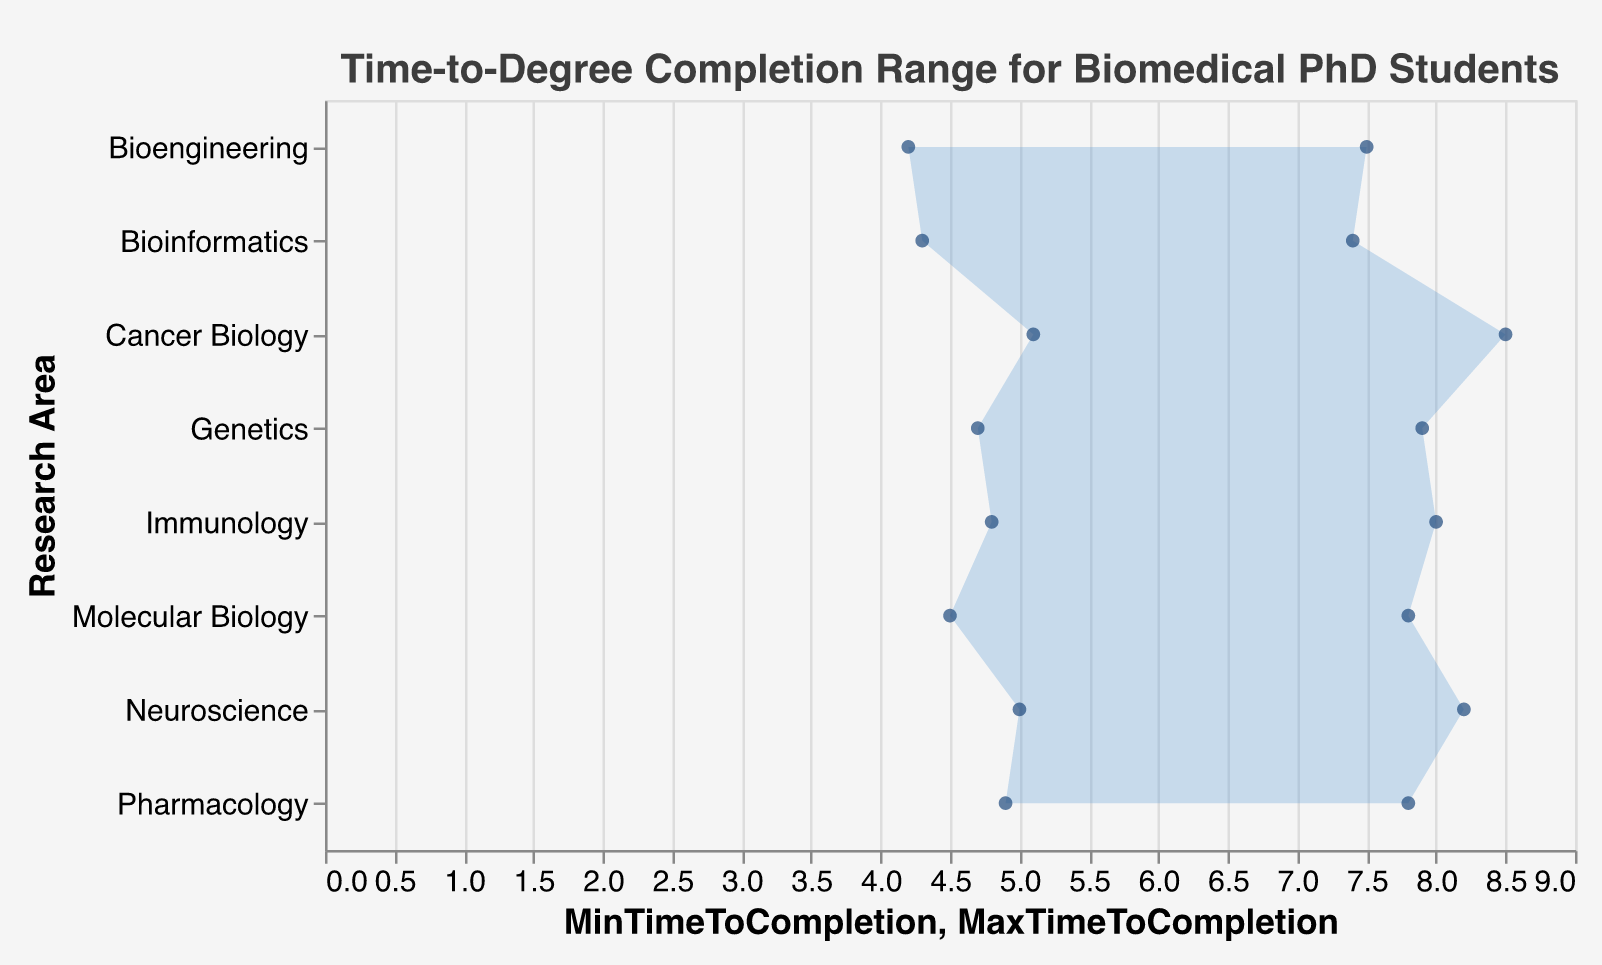How long is the maximum completion time for Cancer Biology? To find the maximum completion time for Cancer Biology, look at the "MaxTimeToCompletion" value for Cancer Biology, which is indicated as 8.5 years in the data.
Answer: 8.5 years Which research area has the shortest minimum time-to-degree completion? Compare the "MinTimeToCompletion" values for all research areas. Bioengineering has the shortest minimum time-to-degree completion with 4.2 years.
Answer: Bioengineering What's the range of completion times for Neuroscience? The range is the difference between the maximum and minimum completion times. For Neuroscience, it’s 8.2 - 5.0 = 3.2 years.
Answer: 3.2 years Which research area has both the highest minimum and the highest maximum time-to-degree completion? Check both minimum and maximum values across all research areas. Cancer Biology has the highest minimum (5.1 years) and also the highest maximum (8.5 years) values.
Answer: Cancer Biology What is the average maximum completion time across all research areas? Add all the maximum completion times and divide by the number of research areas: (7.8 + 8.2 + 7.5 + 7.9 + 8.0 + 8.5 + 7.4 + 7.8) / 8 = 61.1 / 8 = 7.64 years.
Answer: 7.64 years How does the range of time-to-degree completion for Immunology compare to that for Genetics? Calculate the range for both research areas: Immunology’s range is 8.0 - 4.8 = 3.2 years, and Genetics’ range is 7.9 - 4.7 = 3.2 years. Both ranges are equal.
Answer: Both are equal (3.2 years) For which research area does the time-to-degree completion span the smallest interval? The smallest interval is determined by the difference between the maximum and minimum times. The smallest span is for Bioinformatics, with a range of 7.4 - 4.3 = 3.1 years.
Answer: Bioinformatics What is the difference in the maximum completion time between the research areas with the shortest and longest maximum completion times? Identify the maximum times for each research area and find the difference between the shortest and longest: 8.5 years (Cancer Biology) - 7.4 years (Bioinformatics) = 1.1 years.
Answer: 1.1 years Which research area shows the largest gap between its minimum and maximum completion times? Calculate the gaps for each research area and find the largest: Cancer Biology has the largest gap with 8.5 - 5.1 = 3.4 years.
Answer: Cancer Biology 